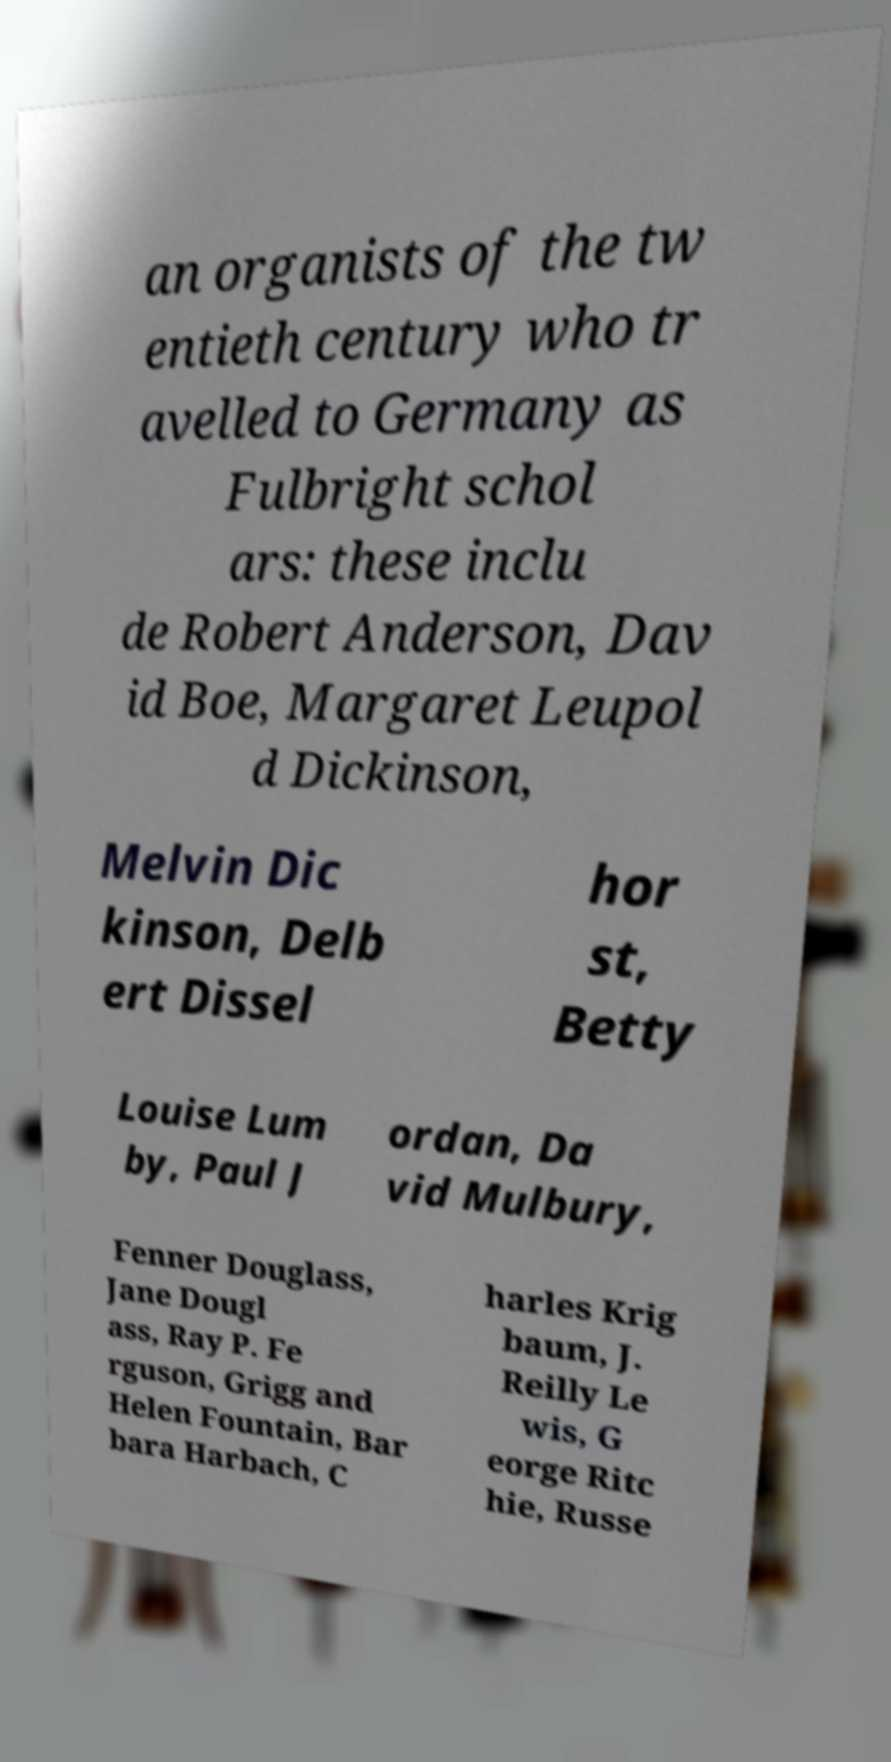There's text embedded in this image that I need extracted. Can you transcribe it verbatim? an organists of the tw entieth century who tr avelled to Germany as Fulbright schol ars: these inclu de Robert Anderson, Dav id Boe, Margaret Leupol d Dickinson, Melvin Dic kinson, Delb ert Dissel hor st, Betty Louise Lum by, Paul J ordan, Da vid Mulbury, Fenner Douglass, Jane Dougl ass, Ray P. Fe rguson, Grigg and Helen Fountain, Bar bara Harbach, C harles Krig baum, J. Reilly Le wis, G eorge Ritc hie, Russe 